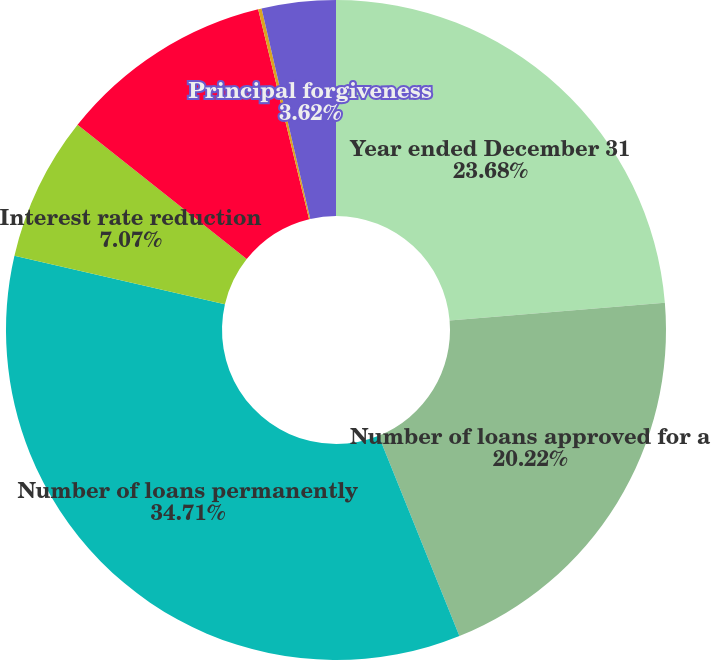Convert chart to OTSL. <chart><loc_0><loc_0><loc_500><loc_500><pie_chart><fcel>Year ended December 31<fcel>Number of loans approved for a<fcel>Number of loans permanently<fcel>Interest rate reduction<fcel>Term or payment extension<fcel>Principal and/or interest<fcel>Principal forgiveness<nl><fcel>23.68%<fcel>20.22%<fcel>34.71%<fcel>7.07%<fcel>10.53%<fcel>0.17%<fcel>3.62%<nl></chart> 